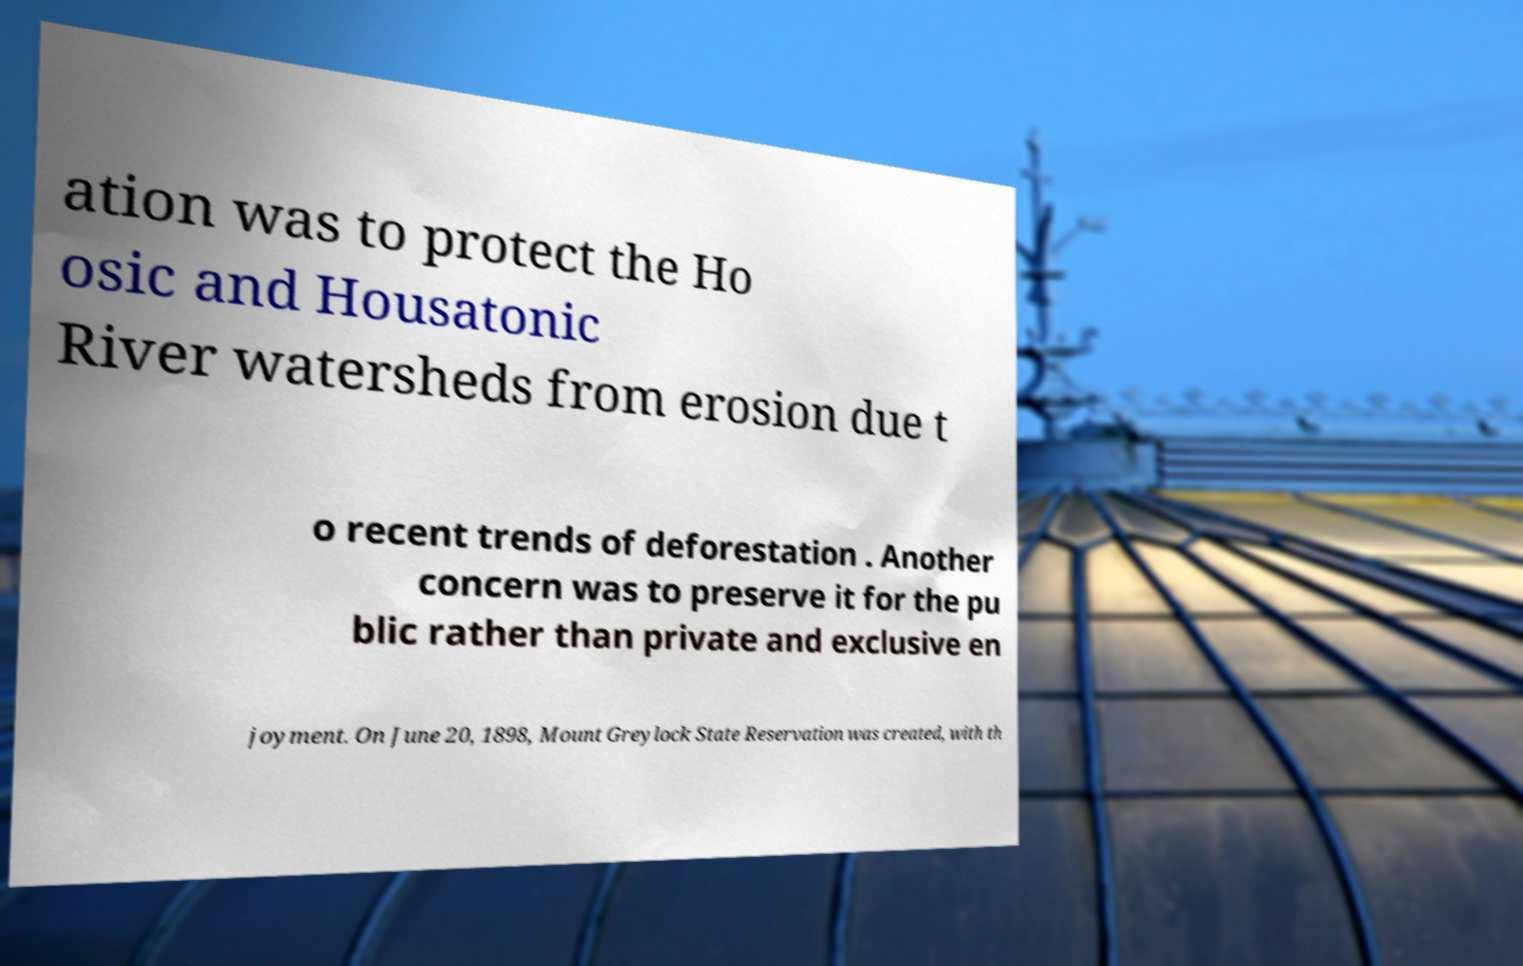What messages or text are displayed in this image? I need them in a readable, typed format. ation was to protect the Ho osic and Housatonic River watersheds from erosion due t o recent trends of deforestation . Another concern was to preserve it for the pu blic rather than private and exclusive en joyment. On June 20, 1898, Mount Greylock State Reservation was created, with th 